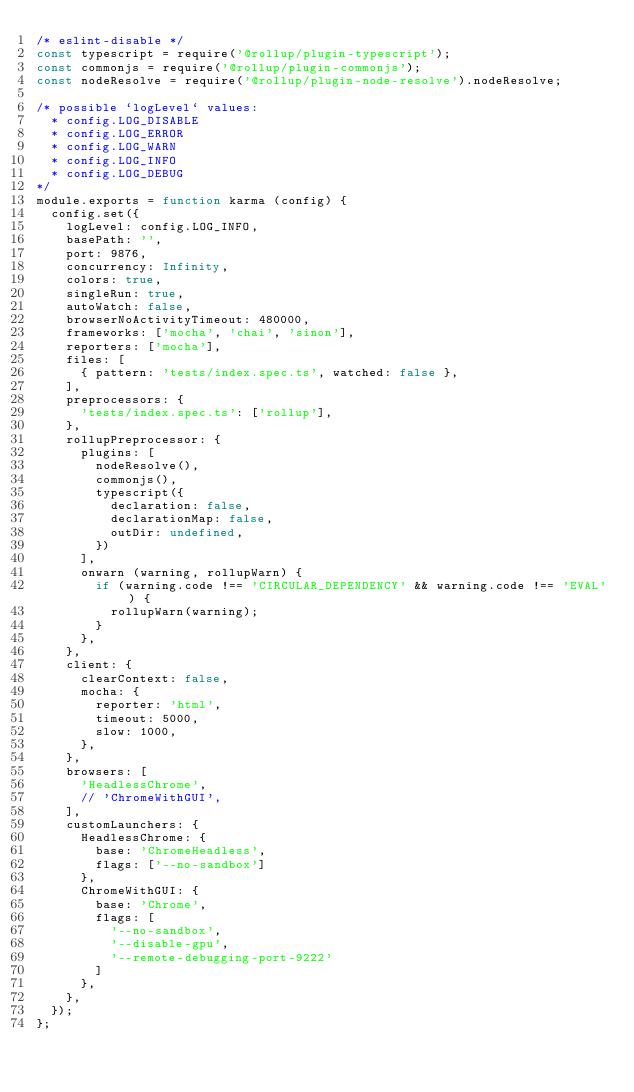<code> <loc_0><loc_0><loc_500><loc_500><_JavaScript_>/* eslint-disable */
const typescript = require('@rollup/plugin-typescript');
const commonjs = require('@rollup/plugin-commonjs');
const nodeResolve = require('@rollup/plugin-node-resolve').nodeResolve;

/* possible `logLevel` values:
 	* config.LOG_DISABLE
 	* config.LOG_ERROR
 	* config.LOG_WARN
 	* config.LOG_INFO
 	* config.LOG_DEBUG
*/
module.exports = function karma (config) {
	config.set({
		logLevel: config.LOG_INFO,
		basePath: '',
		port: 9876,
		concurrency: Infinity,
		colors: true,
		singleRun: true,
		autoWatch: false,
		browserNoActivityTimeout: 480000,
		frameworks: ['mocha', 'chai', 'sinon'],
		reporters: ['mocha'],
		files: [
			{ pattern: 'tests/index.spec.ts', watched: false },
		],
		preprocessors: {
			'tests/index.spec.ts': ['rollup'],
		},
		rollupPreprocessor: {
			plugins: [
				nodeResolve(),
				commonjs(),
				typescript({
					declaration: false,
					declarationMap: false,
					outDir: undefined,
				})
			],
			onwarn (warning, rollupWarn) {
				if (warning.code !== 'CIRCULAR_DEPENDENCY' && warning.code !== 'EVAL') {
					rollupWarn(warning);
				}
			},
		},
		client: {
			clearContext: false,
			mocha: {
				reporter: 'html',
				timeout: 5000,
				slow: 1000,
			},
		},
		browsers: [
			'HeadlessChrome',
			// 'ChromeWithGUI',
		],
		customLaunchers: {
			HeadlessChrome: {
				base: 'ChromeHeadless',
				flags: ['--no-sandbox']
			},
			ChromeWithGUI: {
				base: 'Chrome',
				flags: [
					'--no-sandbox',
					'--disable-gpu',
					'--remote-debugging-port-9222'
				]
			},
		},
	});
};
</code> 